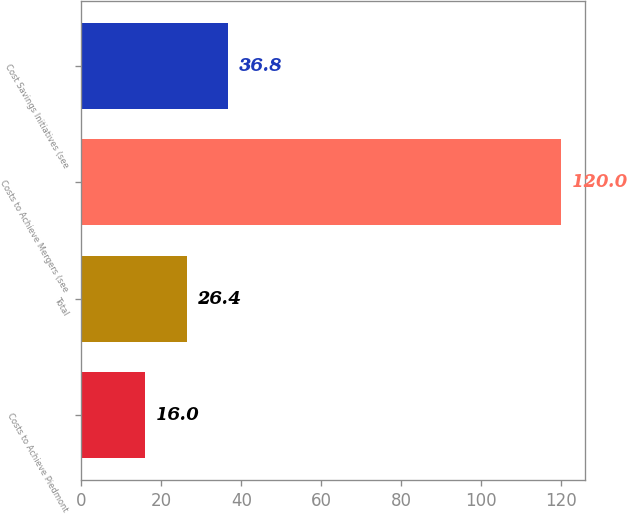Convert chart. <chart><loc_0><loc_0><loc_500><loc_500><bar_chart><fcel>Costs to Achieve Piedmont<fcel>Total<fcel>Costs to Achieve Mergers (see<fcel>Cost Savings Initiatives (see<nl><fcel>16<fcel>26.4<fcel>120<fcel>36.8<nl></chart> 